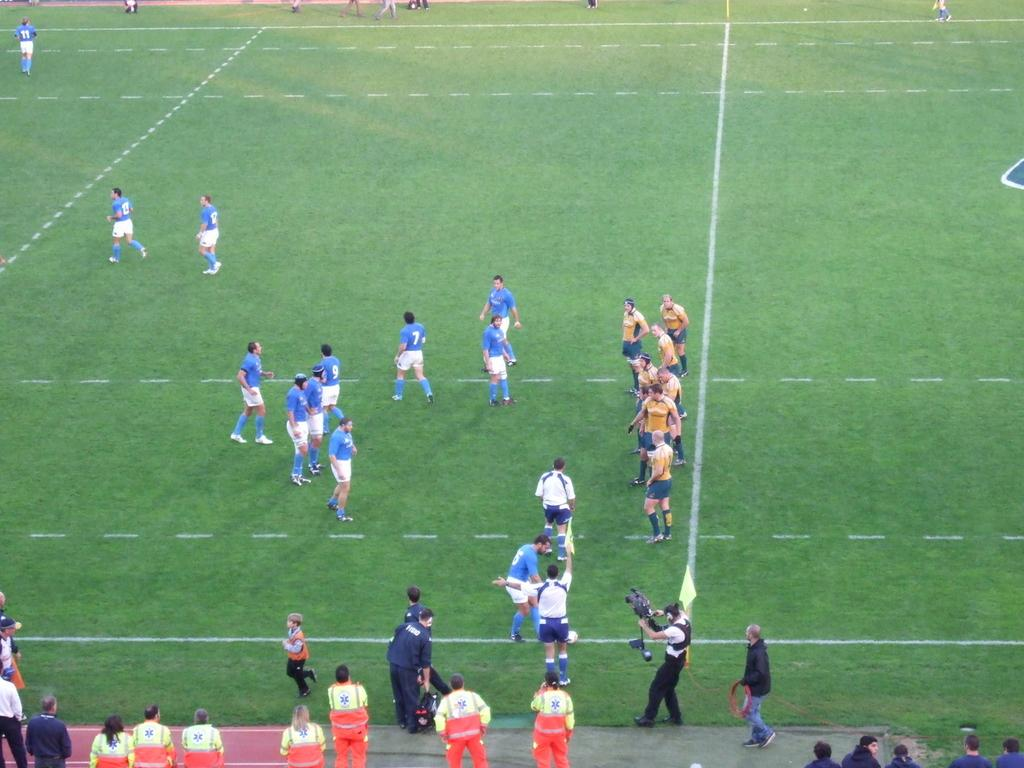Who is present in the image? There are people in the image. Where are some of the people located? Some people are on a football ground. What is the person with the video camera doing? The person holding the video camera is likely recording the scene. What type of farm animals can be seen in the image? There are no farm animals present in the image. How many apples are being used to make soap in the image? There is no mention of apples or soap in the image. 